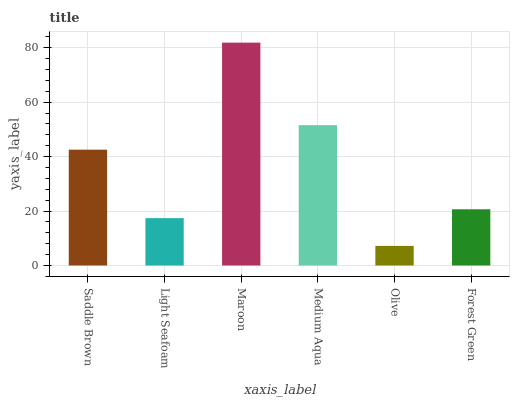Is Olive the minimum?
Answer yes or no. Yes. Is Maroon the maximum?
Answer yes or no. Yes. Is Light Seafoam the minimum?
Answer yes or no. No. Is Light Seafoam the maximum?
Answer yes or no. No. Is Saddle Brown greater than Light Seafoam?
Answer yes or no. Yes. Is Light Seafoam less than Saddle Brown?
Answer yes or no. Yes. Is Light Seafoam greater than Saddle Brown?
Answer yes or no. No. Is Saddle Brown less than Light Seafoam?
Answer yes or no. No. Is Saddle Brown the high median?
Answer yes or no. Yes. Is Forest Green the low median?
Answer yes or no. Yes. Is Forest Green the high median?
Answer yes or no. No. Is Saddle Brown the low median?
Answer yes or no. No. 